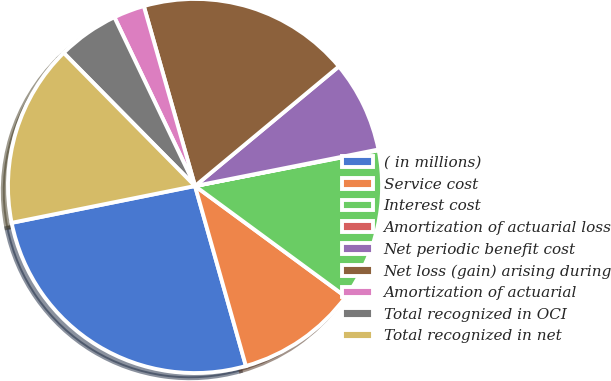Convert chart. <chart><loc_0><loc_0><loc_500><loc_500><pie_chart><fcel>( in millions)<fcel>Service cost<fcel>Interest cost<fcel>Amortization of actuarial loss<fcel>Net periodic benefit cost<fcel>Net loss (gain) arising during<fcel>Amortization of actuarial<fcel>Total recognized in OCI<fcel>Total recognized in net<nl><fcel>26.23%<fcel>10.53%<fcel>13.15%<fcel>0.06%<fcel>7.91%<fcel>18.38%<fcel>2.68%<fcel>5.3%<fcel>15.76%<nl></chart> 